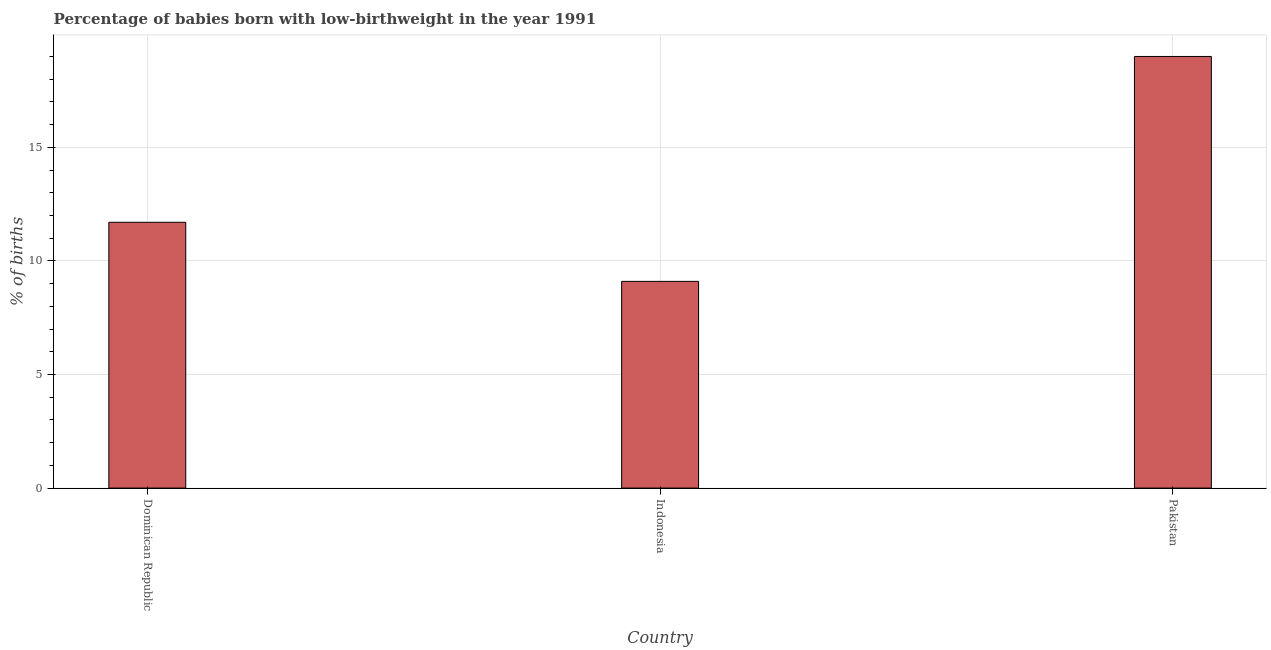What is the title of the graph?
Provide a succinct answer. Percentage of babies born with low-birthweight in the year 1991. What is the label or title of the Y-axis?
Provide a short and direct response. % of births. Across all countries, what is the minimum percentage of babies who were born with low-birthweight?
Give a very brief answer. 9.1. In which country was the percentage of babies who were born with low-birthweight maximum?
Offer a terse response. Pakistan. In which country was the percentage of babies who were born with low-birthweight minimum?
Offer a very short reply. Indonesia. What is the sum of the percentage of babies who were born with low-birthweight?
Give a very brief answer. 39.8. What is the average percentage of babies who were born with low-birthweight per country?
Ensure brevity in your answer.  13.27. What is the ratio of the percentage of babies who were born with low-birthweight in Dominican Republic to that in Pakistan?
Your answer should be compact. 0.62. Is the percentage of babies who were born with low-birthweight in Dominican Republic less than that in Indonesia?
Offer a very short reply. No. Is the difference between the percentage of babies who were born with low-birthweight in Dominican Republic and Pakistan greater than the difference between any two countries?
Provide a short and direct response. No. What is the difference between the highest and the second highest percentage of babies who were born with low-birthweight?
Offer a very short reply. 7.3. What is the difference between the highest and the lowest percentage of babies who were born with low-birthweight?
Ensure brevity in your answer.  9.9. Are all the bars in the graph horizontal?
Give a very brief answer. No. How many countries are there in the graph?
Offer a terse response. 3. What is the % of births in Dominican Republic?
Keep it short and to the point. 11.7. What is the % of births in Indonesia?
Your answer should be very brief. 9.1. What is the difference between the % of births in Dominican Republic and Indonesia?
Offer a terse response. 2.6. What is the difference between the % of births in Dominican Republic and Pakistan?
Offer a very short reply. -7.3. What is the ratio of the % of births in Dominican Republic to that in Indonesia?
Provide a short and direct response. 1.29. What is the ratio of the % of births in Dominican Republic to that in Pakistan?
Provide a succinct answer. 0.62. What is the ratio of the % of births in Indonesia to that in Pakistan?
Offer a very short reply. 0.48. 